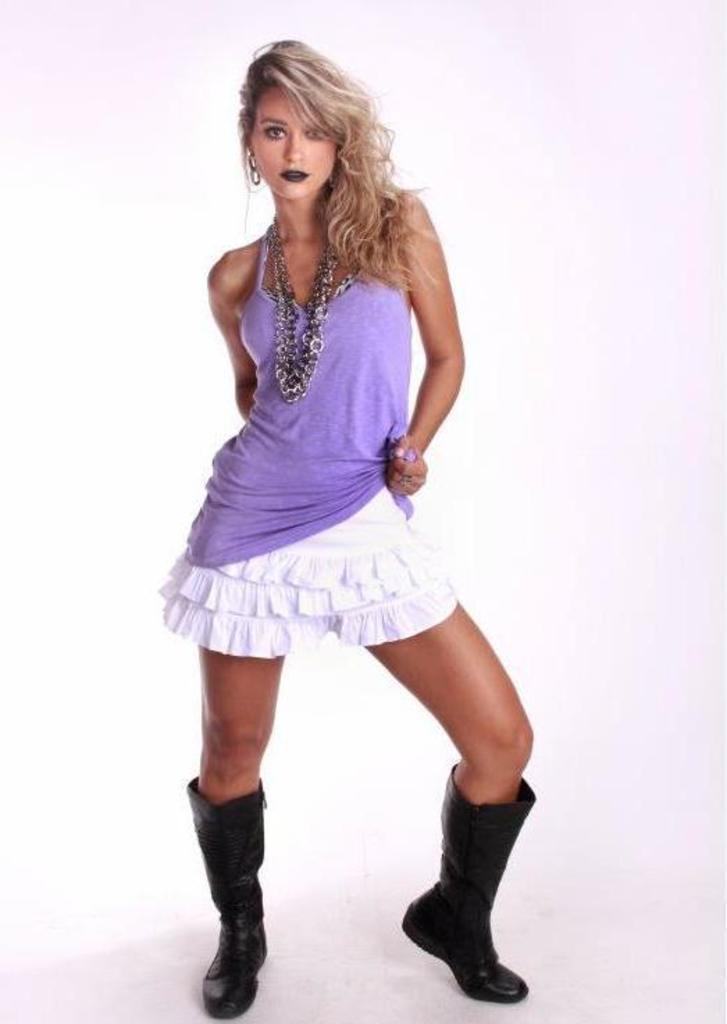Can you describe this image briefly? There is a woman standing. In the background it is white. 